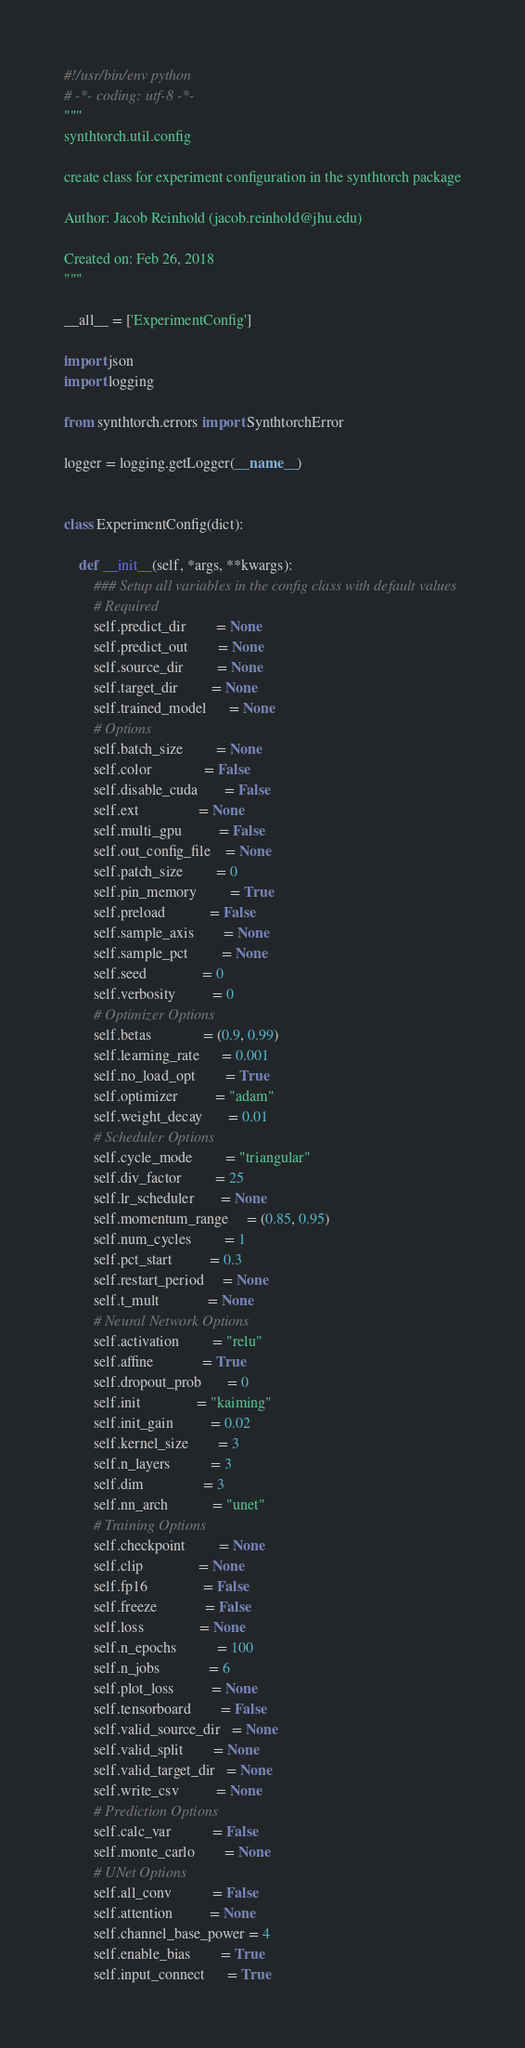Convert code to text. <code><loc_0><loc_0><loc_500><loc_500><_Python_>#!/usr/bin/env python
# -*- coding: utf-8 -*-
"""
synthtorch.util.config

create class for experiment configuration in the synthtorch package

Author: Jacob Reinhold (jacob.reinhold@jhu.edu)

Created on: Feb 26, 2018
"""

__all__ = ['ExperimentConfig']

import json
import logging

from synthtorch.errors import SynthtorchError

logger = logging.getLogger(__name__)


class ExperimentConfig(dict):

    def __init__(self, *args, **kwargs):
        ### Setup all variables in the config class with default values
        # Required
        self.predict_dir        = None
        self.predict_out        = None
        self.source_dir         = None
        self.target_dir         = None
        self.trained_model      = None
        # Options
        self.batch_size         = None
        self.color              = False
        self.disable_cuda       = False
        self.ext                = None
        self.multi_gpu          = False
        self.out_config_file    = None
        self.patch_size         = 0
        self.pin_memory         = True
        self.preload            = False
        self.sample_axis        = None
        self.sample_pct         = None
        self.seed               = 0
        self.verbosity          = 0
        # Optimizer Options
        self.betas              = (0.9, 0.99)
        self.learning_rate      = 0.001
        self.no_load_opt        = True
        self.optimizer          = "adam"
        self.weight_decay       = 0.01
        # Scheduler Options
        self.cycle_mode         = "triangular"
        self.div_factor         = 25
        self.lr_scheduler       = None
        self.momentum_range     = (0.85, 0.95)
        self.num_cycles         = 1
        self.pct_start          = 0.3
        self.restart_period     = None
        self.t_mult             = None
        # Neural Network Options
        self.activation         = "relu"
        self.affine             = True
        self.dropout_prob       = 0
        self.init               = "kaiming"
        self.init_gain          = 0.02
        self.kernel_size        = 3
        self.n_layers           = 3
        self.dim                = 3
        self.nn_arch            = "unet"
        # Training Options
        self.checkpoint         = None
        self.clip               = None
        self.fp16               = False
        self.freeze             = False
        self.loss               = None
        self.n_epochs           = 100
        self.n_jobs             = 6
        self.plot_loss          = None
        self.tensorboard        = False
        self.valid_source_dir   = None
        self.valid_split        = None
        self.valid_target_dir   = None
        self.write_csv          = None
        # Prediction Options
        self.calc_var           = False
        self.monte_carlo        = None
        # UNet Options
        self.all_conv           = False
        self.attention          = None
        self.channel_base_power = 4
        self.enable_bias        = True
        self.input_connect      = True</code> 